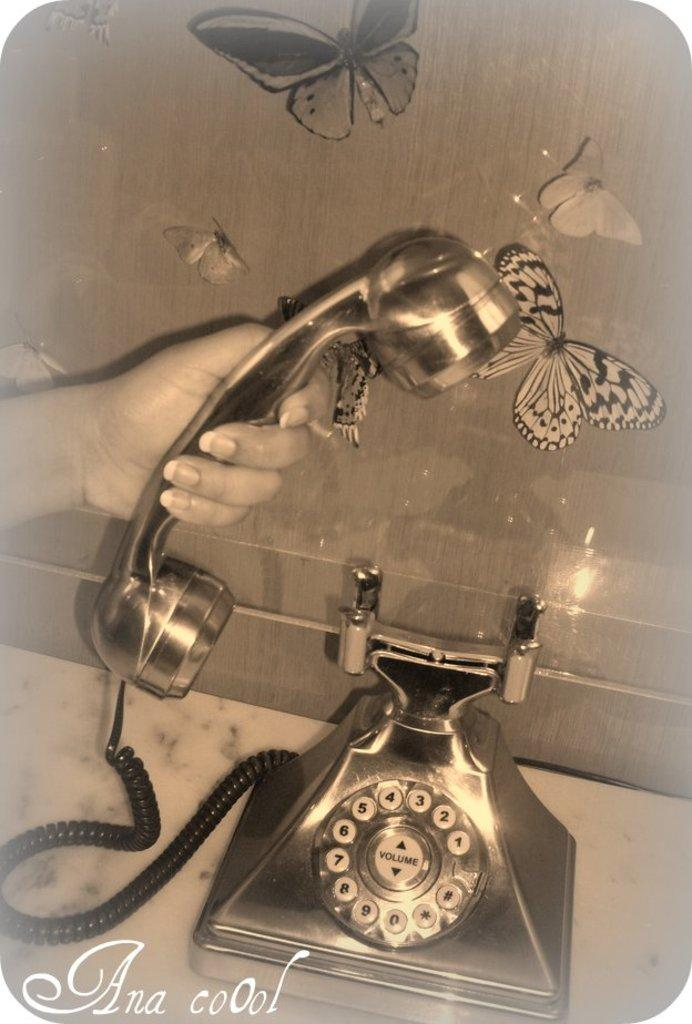What object is being used by the person in the image? There is a telephone in the image, and a person is holding it. What can be seen on the wall in the background of the image? There are butterflies on the wall in the background of the image. Is there any text present in the image? Yes, there is some text at the bottom of the image. What type of collar is the person wearing in the image? There is no collar visible in the image, as the person is holding a telephone and not wearing any clothing. 